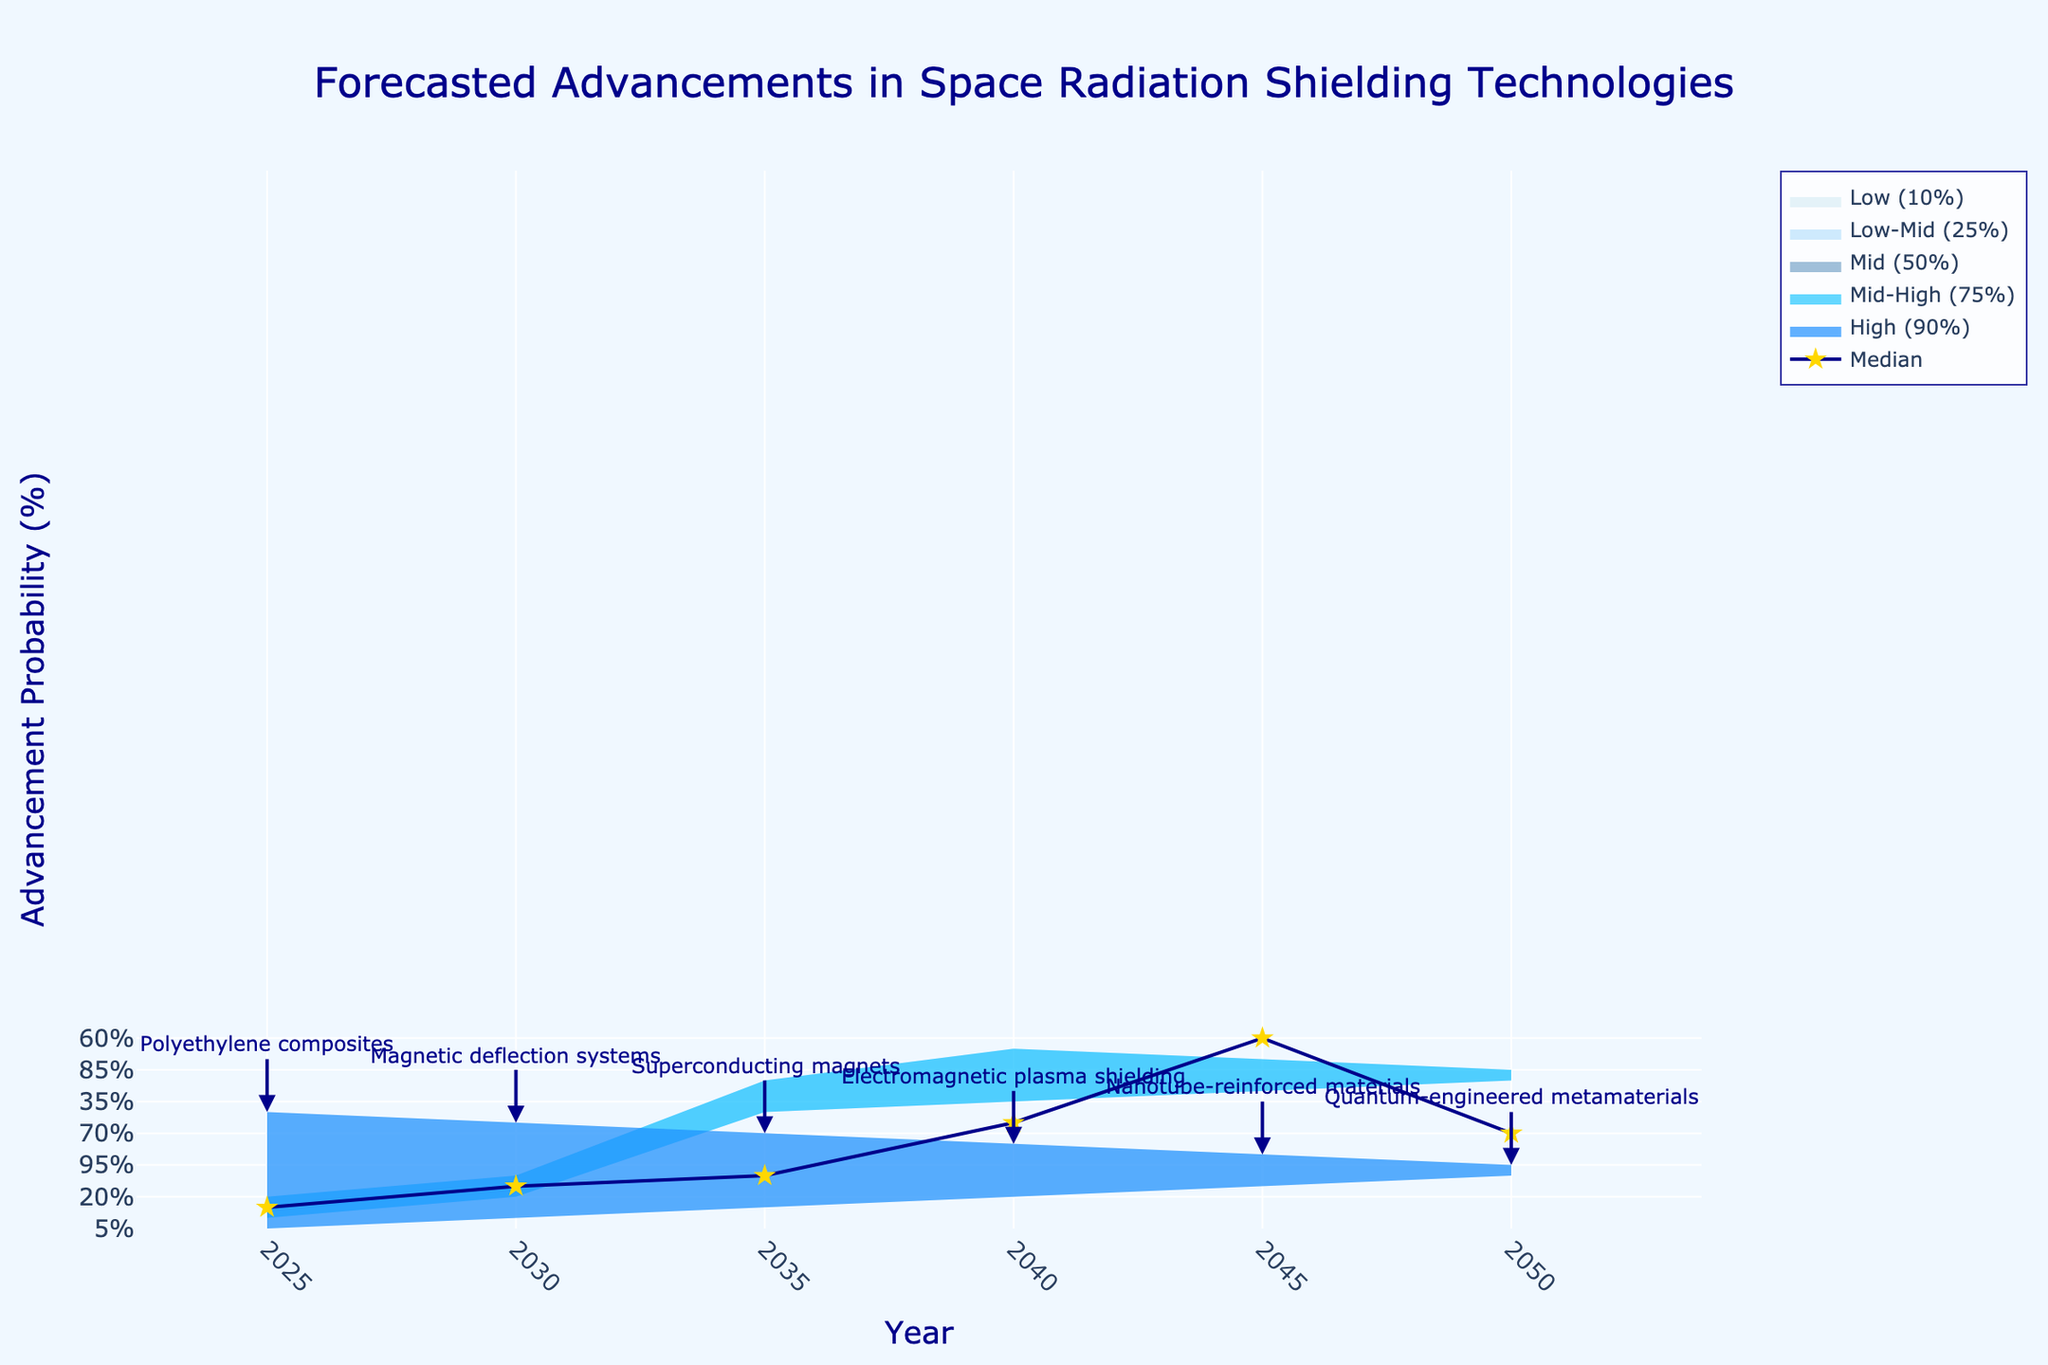What is the title of the chart? The title of the chart is displayed at the top center of the figure. It reads "Forecasted Advancements in Space Radiation Shielding Technologies".
Answer: Forecasted Advancements in Space Radiation Shielding Technologies What are the x-axis and y-axis titles? The x-axis title can be found at the horizontal axis, labeled "Year", and the y-axis title is at the vertical axis, labeled "Advancement Probability (%)".
Answer: Year, Advancement Probability (%) Which year shows the highest advancement probability for Quantum-engineered metamaterials? To find this, look for the highest y-axis value annotated with "Quantum-engineered metamaterials" on the plot, which is in the year 2050.
Answer: 2050 What is the median advancement probability for Superconducting magnets in 2035? Check the "Mid (50%)" line or area in the chart and find the value for the year 2035, which is labeled as "Superconducting magnets". The value is 40%.
Answer: 40% Compare the median advancement probabilities between Magnetic deflection systems in 2030 and Nanotube-reinforced materials in 2045. Which one is higher? Locate the "Mid (50%)" values for both years and technologies. For 2030, Magnetic deflection systems have a median probability of 30%, and for 2045, Nanotube-reinforced materials have a median probability of 60%. Therefore, Nanotube-reinforced materials have a higher median probability.
Answer: Nanotube-reinforced materials What is the range of advancement probabilities for Electromagnetic plasma shielding in 2040? Find the low (10%) and high (90%) percentiles for the year 2040. The values are 20% and 80%, respectively, giving the range from 20% to 80%.
Answer: 20% to 80% How does the advancement probability of Polyethylene composites in 2025 compare to that of Magnetic deflection systems in 2030 at the 75th percentile? Locate the "Mid-High (75%)" values for both years and technologies. For Polyethylene composites in 2025, the value is 20%, and for Magnetic deflection systems in 2030, the value is 40%. Magnetic deflection systems have a higher advancement probability at the 75th percentile.
Answer: Magnetic deflection systems Which technology has the largest increase in median advancement probability from 2025 to 2050? Calculate the differences for the median (50%) line. Polyethylene composites in 2025 have a median probability of 15%, and Quantum-engineered metamaterials in 2050 have a median probability of 70%. The increase for Quantum-engineered metamaterials is the largest: 70% - 15% = 55%.
Answer: Quantum-engineered metamaterials What is the color fill for the Low (10%) percentile in the chart? The Low (10%) percentile is represented by a color fill with a light blue shade. Observing the figure, it corresponds to the color 'rgba(173, 216, 230, 0.3)'.
Answer: light blue 